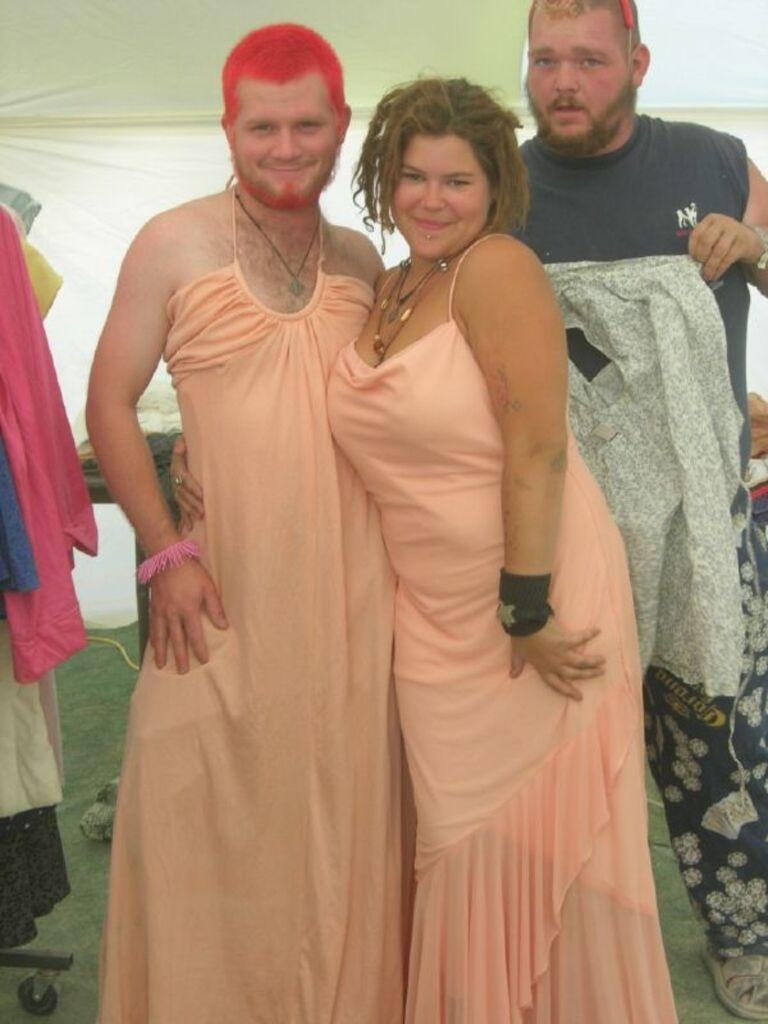How many people are in the image? There are three persons in the image. What are the two persons in the front doing? They are standing in the front and are smiling. What is the man on the right side holding? The man on the right side is holding a cloth. What can be seen on the left side of the image? There are some clothes on the left side of the image. What type of agreement is being signed by the persons in the image? There is no indication in the image that any agreement is being signed; the persons are simply standing and smiling. What kind of vessel is being used by the persons in the image? There is no vessel present in the image; it features three persons standing and a man holding a cloth. 